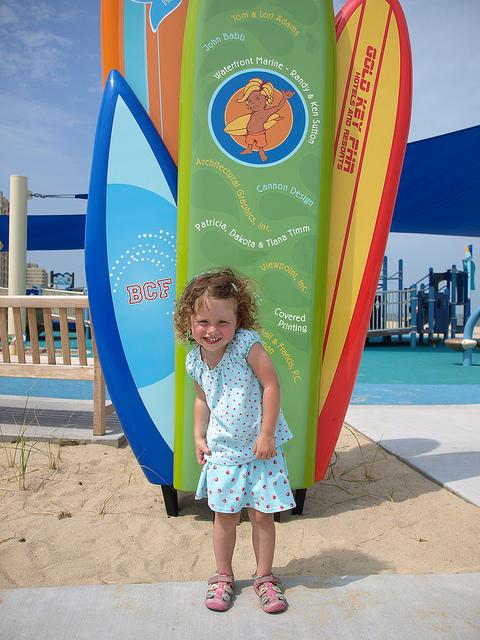What is the girl standing in front of?
Be succinct. Surfboards. What pattern is on the little girl's outfit?
Keep it brief. Polka dot. Are all the boards the same size?
Concise answer only. No. 